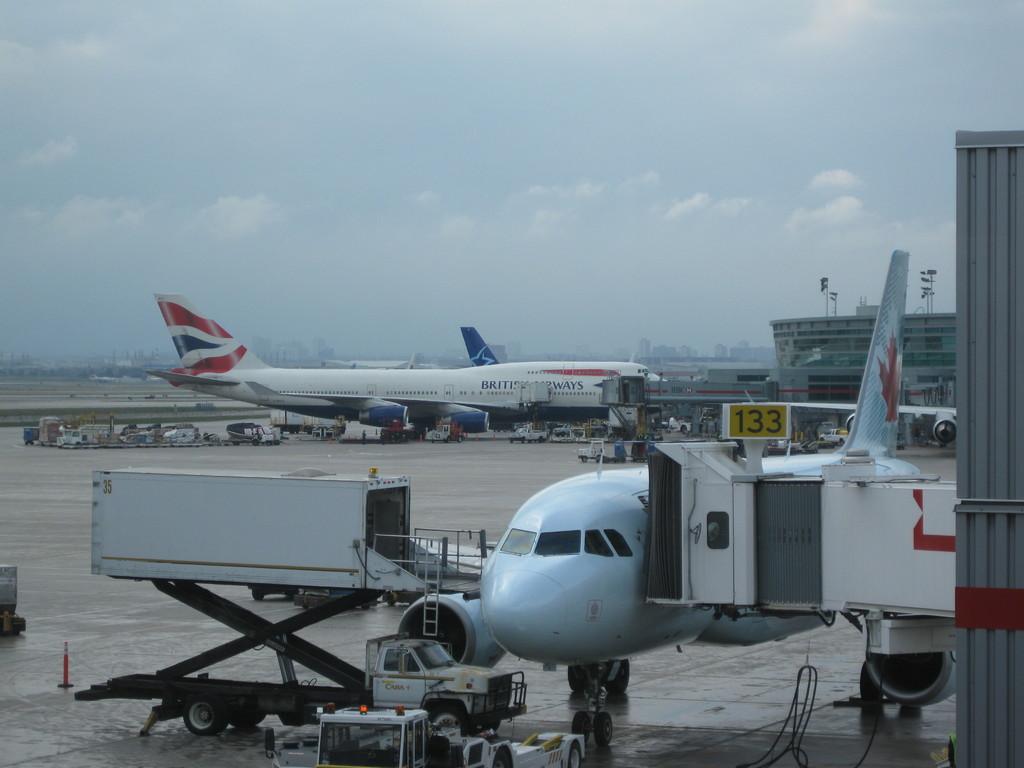What is the airline of the plane in taxi progress?
Provide a succinct answer. British airways. 